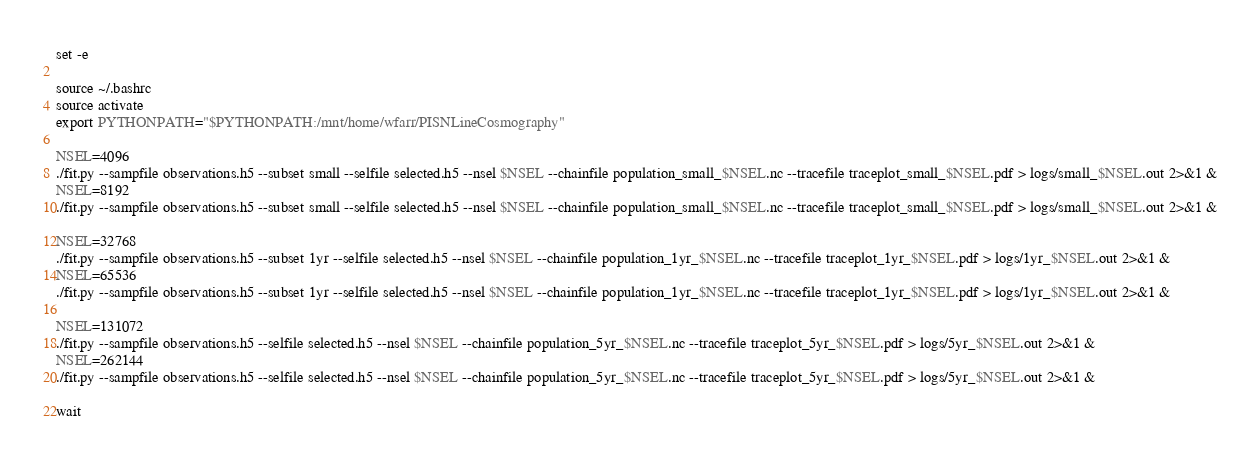<code> <loc_0><loc_0><loc_500><loc_500><_Bash_>set -e

source ~/.bashrc
source activate
export PYTHONPATH="$PYTHONPATH:/mnt/home/wfarr/PISNLineCosmography"

NSEL=4096
./fit.py --sampfile observations.h5 --subset small --selfile selected.h5 --nsel $NSEL --chainfile population_small_$NSEL.nc --tracefile traceplot_small_$NSEL.pdf > logs/small_$NSEL.out 2>&1 &
NSEL=8192
./fit.py --sampfile observations.h5 --subset small --selfile selected.h5 --nsel $NSEL --chainfile population_small_$NSEL.nc --tracefile traceplot_small_$NSEL.pdf > logs/small_$NSEL.out 2>&1 &

NSEL=32768
./fit.py --sampfile observations.h5 --subset 1yr --selfile selected.h5 --nsel $NSEL --chainfile population_1yr_$NSEL.nc --tracefile traceplot_1yr_$NSEL.pdf > logs/1yr_$NSEL.out 2>&1 &
NSEL=65536
./fit.py --sampfile observations.h5 --subset 1yr --selfile selected.h5 --nsel $NSEL --chainfile population_1yr_$NSEL.nc --tracefile traceplot_1yr_$NSEL.pdf > logs/1yr_$NSEL.out 2>&1 &

NSEL=131072
./fit.py --sampfile observations.h5 --selfile selected.h5 --nsel $NSEL --chainfile population_5yr_$NSEL.nc --tracefile traceplot_5yr_$NSEL.pdf > logs/5yr_$NSEL.out 2>&1 &
NSEL=262144
./fit.py --sampfile observations.h5 --selfile selected.h5 --nsel $NSEL --chainfile population_5yr_$NSEL.nc --tracefile traceplot_5yr_$NSEL.pdf > logs/5yr_$NSEL.out 2>&1 &

wait
</code> 